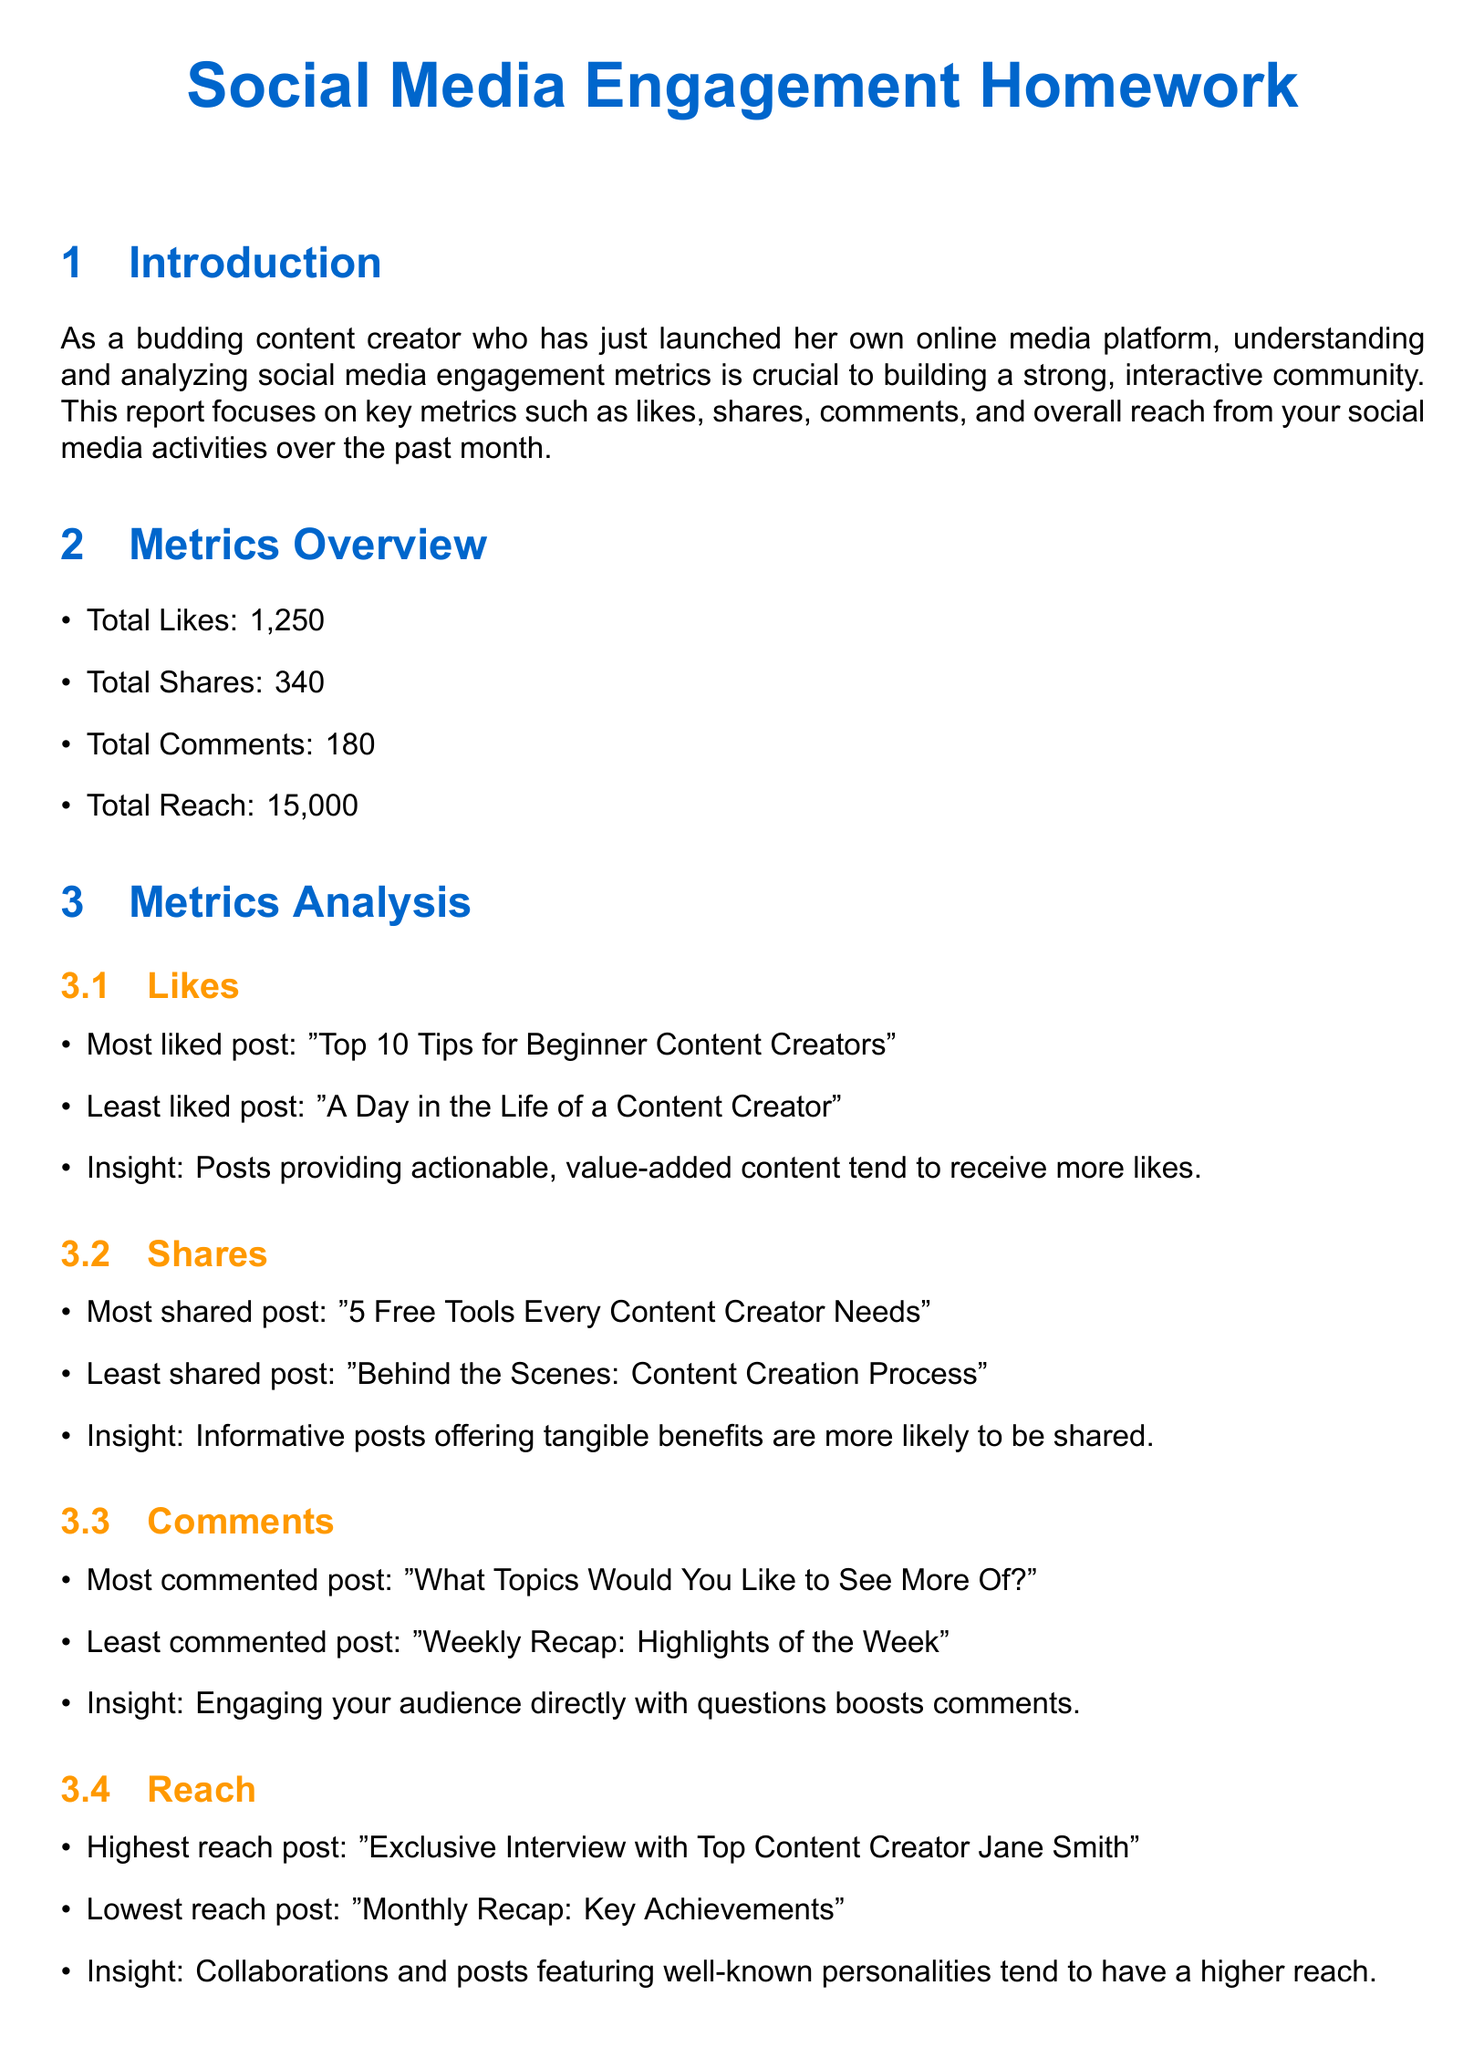What is the total number of likes? The total number of likes is directly stated in the document as part of the metrics overview.
Answer: 1,250 What was the most liked post? The most liked post is identified in the likes section of the metrics analysis.
Answer: "Top 10 Tips for Beginner Content Creators" Which post reached the highest number of shares? The post with the highest shares is specified in the shares section of the metrics analysis.
Answer: "5 Free Tools Every Content Creator Needs" What is the total number of comments? The total number of comments is listed in the metrics overview section of the document.
Answer: 180 Which post had the most comments? The post with the most comments can be found in the comments section of the metrics analysis.
Answer: "What Topics Would You Like to See More Of?" What was the total reach mentioned in the report? The total reach is part of the metrics overview and can be extracted directly.
Answer: 15,000 What strategy is suggested to improve engagement? Strategies are listed in the improvement strategies section of the document, with several suggestions made.
Answer: Increase frequency of high-engagement content Which post features well-known personalities to improve reach? The section on reach discusses posts that feature well-known personalities and mentions the specific post.
Answer: "Exclusive Interview with Top Content Creator Jane Smith" What was the least liked post? The least liked post is indicated in the analysis of likes, reflecting audience preferences.
Answer: "A Day in the Life of a Content Creator" 